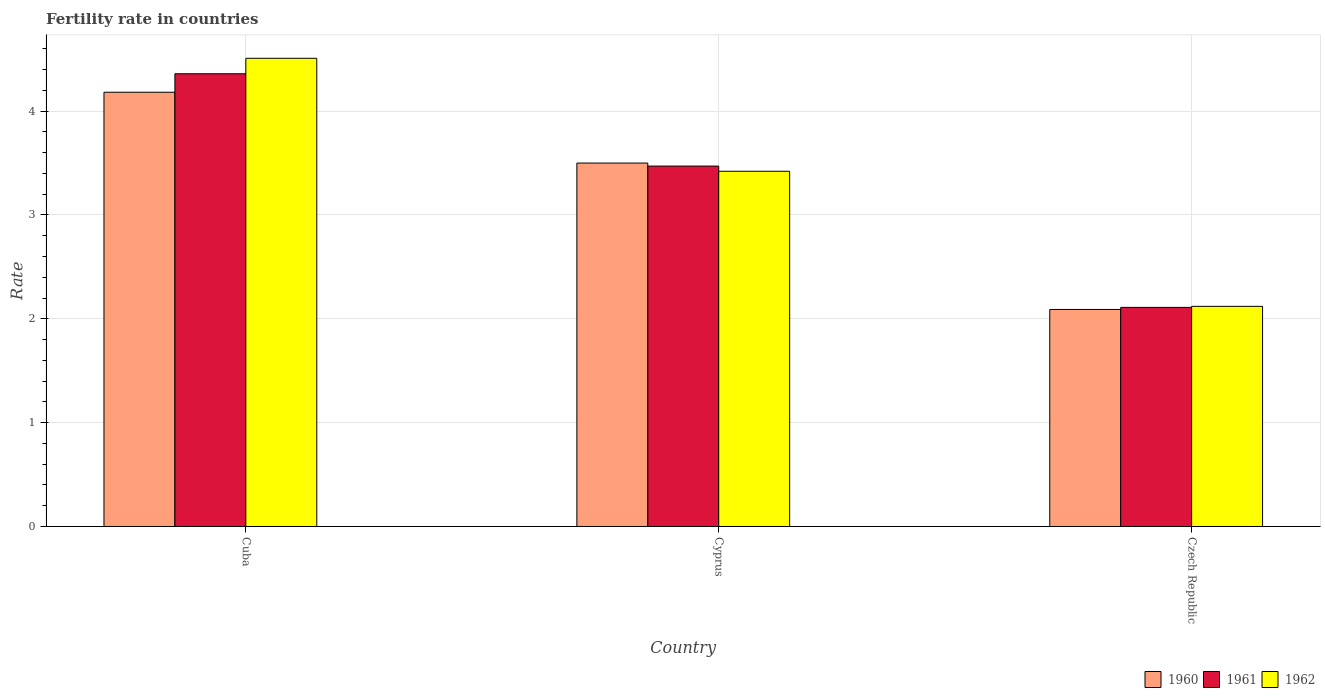How many groups of bars are there?
Give a very brief answer. 3. How many bars are there on the 3rd tick from the left?
Provide a short and direct response. 3. What is the label of the 2nd group of bars from the left?
Offer a very short reply. Cyprus. In how many cases, is the number of bars for a given country not equal to the number of legend labels?
Ensure brevity in your answer.  0. Across all countries, what is the maximum fertility rate in 1960?
Your answer should be compact. 4.18. Across all countries, what is the minimum fertility rate in 1961?
Your answer should be compact. 2.11. In which country was the fertility rate in 1962 maximum?
Provide a short and direct response. Cuba. In which country was the fertility rate in 1960 minimum?
Ensure brevity in your answer.  Czech Republic. What is the total fertility rate in 1960 in the graph?
Provide a succinct answer. 9.77. What is the difference between the fertility rate in 1960 in Cuba and that in Cyprus?
Provide a short and direct response. 0.68. What is the difference between the fertility rate in 1960 in Czech Republic and the fertility rate in 1962 in Cyprus?
Your response must be concise. -1.33. What is the average fertility rate in 1962 per country?
Provide a succinct answer. 3.35. What is the difference between the fertility rate of/in 1960 and fertility rate of/in 1961 in Cyprus?
Give a very brief answer. 0.03. What is the ratio of the fertility rate in 1962 in Cuba to that in Cyprus?
Your answer should be very brief. 1.32. Is the fertility rate in 1960 in Cuba less than that in Czech Republic?
Your answer should be compact. No. What is the difference between the highest and the second highest fertility rate in 1961?
Provide a short and direct response. -1.36. What is the difference between the highest and the lowest fertility rate in 1960?
Provide a short and direct response. 2.09. In how many countries, is the fertility rate in 1960 greater than the average fertility rate in 1960 taken over all countries?
Provide a succinct answer. 2. What does the 2nd bar from the right in Cuba represents?
Offer a very short reply. 1961. Is it the case that in every country, the sum of the fertility rate in 1960 and fertility rate in 1961 is greater than the fertility rate in 1962?
Provide a short and direct response. Yes. How many bars are there?
Provide a succinct answer. 9. Are all the bars in the graph horizontal?
Your answer should be very brief. No. How many countries are there in the graph?
Provide a succinct answer. 3. Are the values on the major ticks of Y-axis written in scientific E-notation?
Ensure brevity in your answer.  No. How are the legend labels stacked?
Make the answer very short. Horizontal. What is the title of the graph?
Make the answer very short. Fertility rate in countries. What is the label or title of the Y-axis?
Your response must be concise. Rate. What is the Rate of 1960 in Cuba?
Provide a short and direct response. 4.18. What is the Rate in 1961 in Cuba?
Offer a very short reply. 4.36. What is the Rate of 1962 in Cuba?
Your answer should be compact. 4.51. What is the Rate of 1961 in Cyprus?
Provide a succinct answer. 3.47. What is the Rate of 1962 in Cyprus?
Your answer should be compact. 3.42. What is the Rate in 1960 in Czech Republic?
Make the answer very short. 2.09. What is the Rate in 1961 in Czech Republic?
Keep it short and to the point. 2.11. What is the Rate in 1962 in Czech Republic?
Your answer should be very brief. 2.12. Across all countries, what is the maximum Rate of 1960?
Your response must be concise. 4.18. Across all countries, what is the maximum Rate of 1961?
Offer a very short reply. 4.36. Across all countries, what is the maximum Rate in 1962?
Ensure brevity in your answer.  4.51. Across all countries, what is the minimum Rate of 1960?
Provide a short and direct response. 2.09. Across all countries, what is the minimum Rate in 1961?
Offer a very short reply. 2.11. Across all countries, what is the minimum Rate of 1962?
Your response must be concise. 2.12. What is the total Rate of 1960 in the graph?
Your response must be concise. 9.77. What is the total Rate of 1961 in the graph?
Your answer should be very brief. 9.94. What is the total Rate in 1962 in the graph?
Keep it short and to the point. 10.05. What is the difference between the Rate in 1960 in Cuba and that in Cyprus?
Provide a short and direct response. 0.68. What is the difference between the Rate of 1961 in Cuba and that in Cyprus?
Provide a short and direct response. 0.89. What is the difference between the Rate of 1962 in Cuba and that in Cyprus?
Ensure brevity in your answer.  1.09. What is the difference between the Rate of 1960 in Cuba and that in Czech Republic?
Offer a terse response. 2.09. What is the difference between the Rate in 1961 in Cuba and that in Czech Republic?
Your response must be concise. 2.25. What is the difference between the Rate of 1962 in Cuba and that in Czech Republic?
Your answer should be compact. 2.39. What is the difference between the Rate of 1960 in Cyprus and that in Czech Republic?
Your answer should be very brief. 1.41. What is the difference between the Rate in 1961 in Cyprus and that in Czech Republic?
Keep it short and to the point. 1.36. What is the difference between the Rate in 1962 in Cyprus and that in Czech Republic?
Provide a succinct answer. 1.3. What is the difference between the Rate of 1960 in Cuba and the Rate of 1961 in Cyprus?
Provide a short and direct response. 0.71. What is the difference between the Rate in 1960 in Cuba and the Rate in 1962 in Cyprus?
Provide a succinct answer. 0.76. What is the difference between the Rate of 1961 in Cuba and the Rate of 1962 in Cyprus?
Provide a succinct answer. 0.94. What is the difference between the Rate of 1960 in Cuba and the Rate of 1961 in Czech Republic?
Offer a very short reply. 2.07. What is the difference between the Rate of 1960 in Cuba and the Rate of 1962 in Czech Republic?
Ensure brevity in your answer.  2.06. What is the difference between the Rate in 1961 in Cuba and the Rate in 1962 in Czech Republic?
Your answer should be compact. 2.24. What is the difference between the Rate in 1960 in Cyprus and the Rate in 1961 in Czech Republic?
Give a very brief answer. 1.39. What is the difference between the Rate of 1960 in Cyprus and the Rate of 1962 in Czech Republic?
Provide a short and direct response. 1.38. What is the difference between the Rate of 1961 in Cyprus and the Rate of 1962 in Czech Republic?
Your answer should be very brief. 1.35. What is the average Rate of 1960 per country?
Offer a very short reply. 3.26. What is the average Rate in 1961 per country?
Give a very brief answer. 3.31. What is the average Rate of 1962 per country?
Ensure brevity in your answer.  3.35. What is the difference between the Rate in 1960 and Rate in 1961 in Cuba?
Offer a very short reply. -0.18. What is the difference between the Rate of 1960 and Rate of 1962 in Cuba?
Give a very brief answer. -0.33. What is the difference between the Rate in 1961 and Rate in 1962 in Cuba?
Give a very brief answer. -0.15. What is the difference between the Rate in 1960 and Rate in 1961 in Cyprus?
Make the answer very short. 0.03. What is the difference between the Rate of 1960 and Rate of 1962 in Cyprus?
Offer a terse response. 0.08. What is the difference between the Rate in 1960 and Rate in 1961 in Czech Republic?
Make the answer very short. -0.02. What is the difference between the Rate in 1960 and Rate in 1962 in Czech Republic?
Ensure brevity in your answer.  -0.03. What is the difference between the Rate of 1961 and Rate of 1962 in Czech Republic?
Make the answer very short. -0.01. What is the ratio of the Rate of 1960 in Cuba to that in Cyprus?
Give a very brief answer. 1.19. What is the ratio of the Rate of 1961 in Cuba to that in Cyprus?
Your answer should be compact. 1.26. What is the ratio of the Rate of 1962 in Cuba to that in Cyprus?
Give a very brief answer. 1.32. What is the ratio of the Rate in 1960 in Cuba to that in Czech Republic?
Keep it short and to the point. 2. What is the ratio of the Rate of 1961 in Cuba to that in Czech Republic?
Make the answer very short. 2.07. What is the ratio of the Rate of 1962 in Cuba to that in Czech Republic?
Offer a terse response. 2.13. What is the ratio of the Rate of 1960 in Cyprus to that in Czech Republic?
Your answer should be very brief. 1.67. What is the ratio of the Rate in 1961 in Cyprus to that in Czech Republic?
Offer a terse response. 1.65. What is the ratio of the Rate of 1962 in Cyprus to that in Czech Republic?
Your answer should be compact. 1.61. What is the difference between the highest and the second highest Rate in 1960?
Keep it short and to the point. 0.68. What is the difference between the highest and the second highest Rate of 1961?
Give a very brief answer. 0.89. What is the difference between the highest and the second highest Rate in 1962?
Your answer should be very brief. 1.09. What is the difference between the highest and the lowest Rate in 1960?
Give a very brief answer. 2.09. What is the difference between the highest and the lowest Rate in 1961?
Your response must be concise. 2.25. What is the difference between the highest and the lowest Rate in 1962?
Make the answer very short. 2.39. 